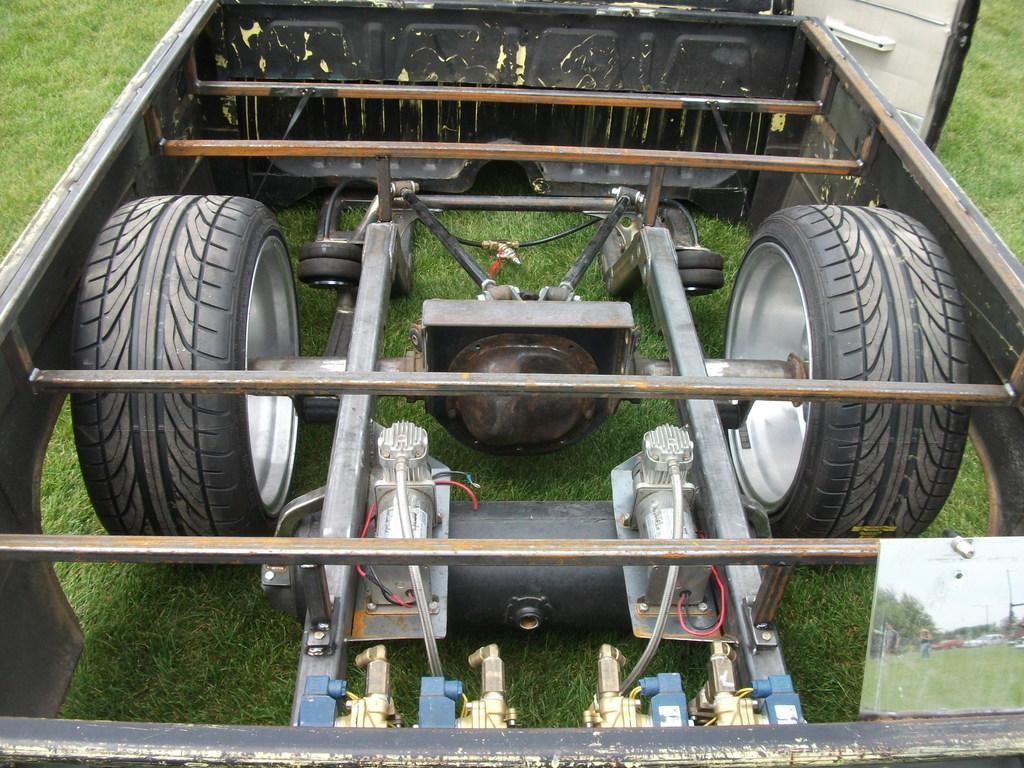In one or two sentences, can you explain what this image depicts? In this picture we can see a parts of a vehicle. There are tires, iron rods and other objects. We can see a sheet on the right side. There are trees, vehicles and person is visible on this sheet. Some grass is visible on the ground. 